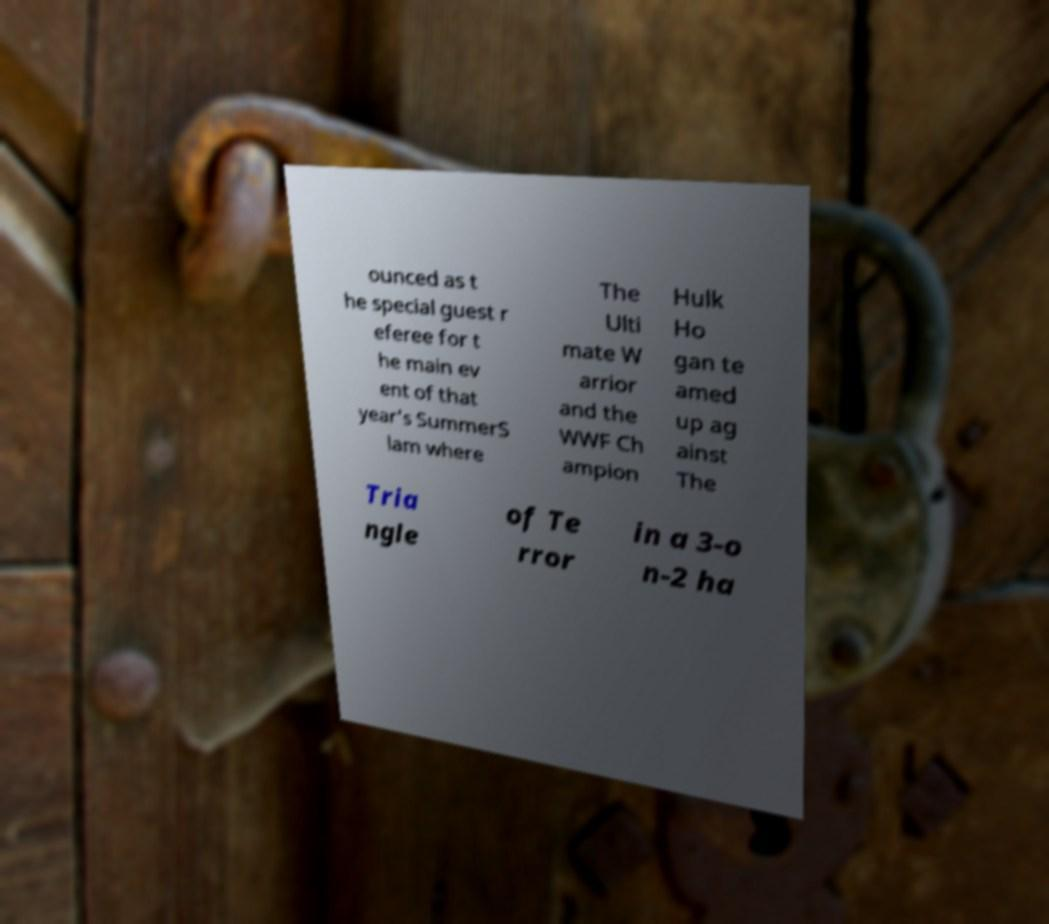Could you assist in decoding the text presented in this image and type it out clearly? ounced as t he special guest r eferee for t he main ev ent of that year's SummerS lam where The Ulti mate W arrior and the WWF Ch ampion Hulk Ho gan te amed up ag ainst The Tria ngle of Te rror in a 3-o n-2 ha 